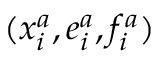Convert formula to latex. <formula><loc_0><loc_0><loc_500><loc_500>( x _ { i } ^ { a } , e _ { i } ^ { a } , f _ { i } ^ { a } )</formula> 